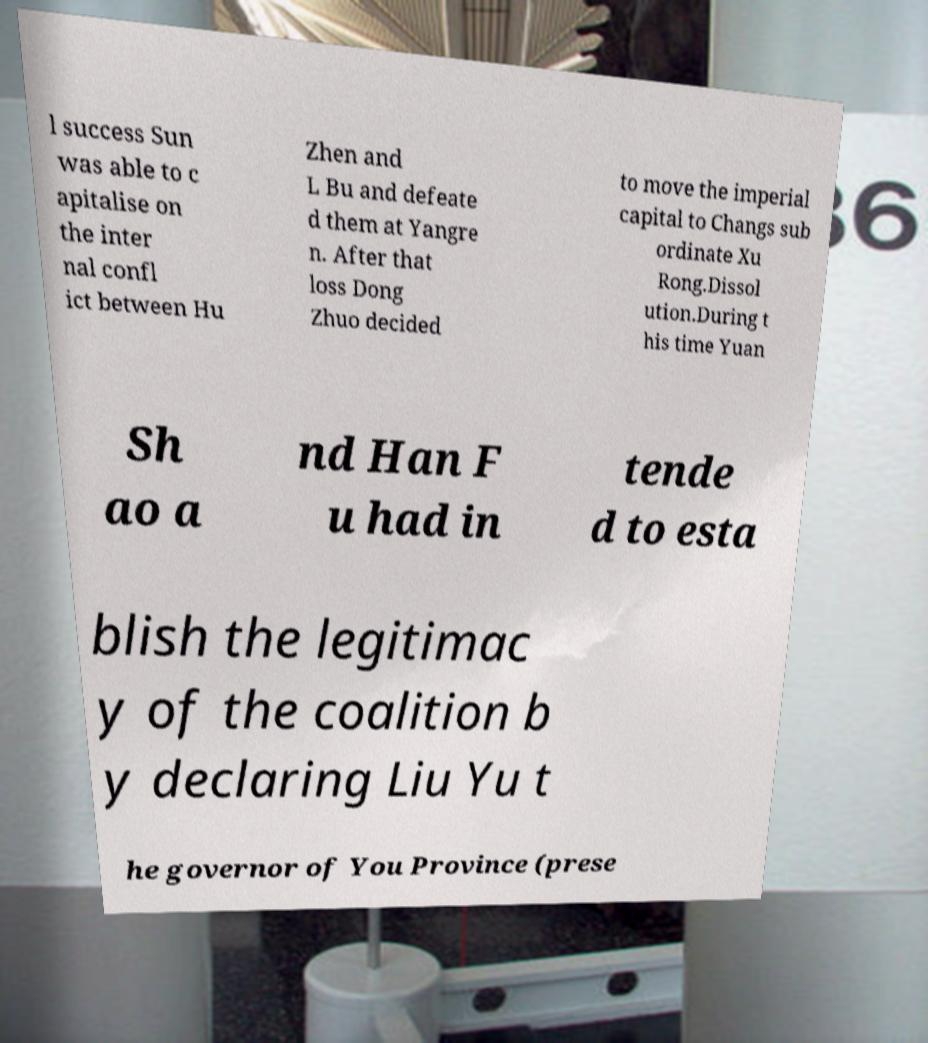There's text embedded in this image that I need extracted. Can you transcribe it verbatim? l success Sun was able to c apitalise on the inter nal confl ict between Hu Zhen and L Bu and defeate d them at Yangre n. After that loss Dong Zhuo decided to move the imperial capital to Changs sub ordinate Xu Rong.Dissol ution.During t his time Yuan Sh ao a nd Han F u had in tende d to esta blish the legitimac y of the coalition b y declaring Liu Yu t he governor of You Province (prese 